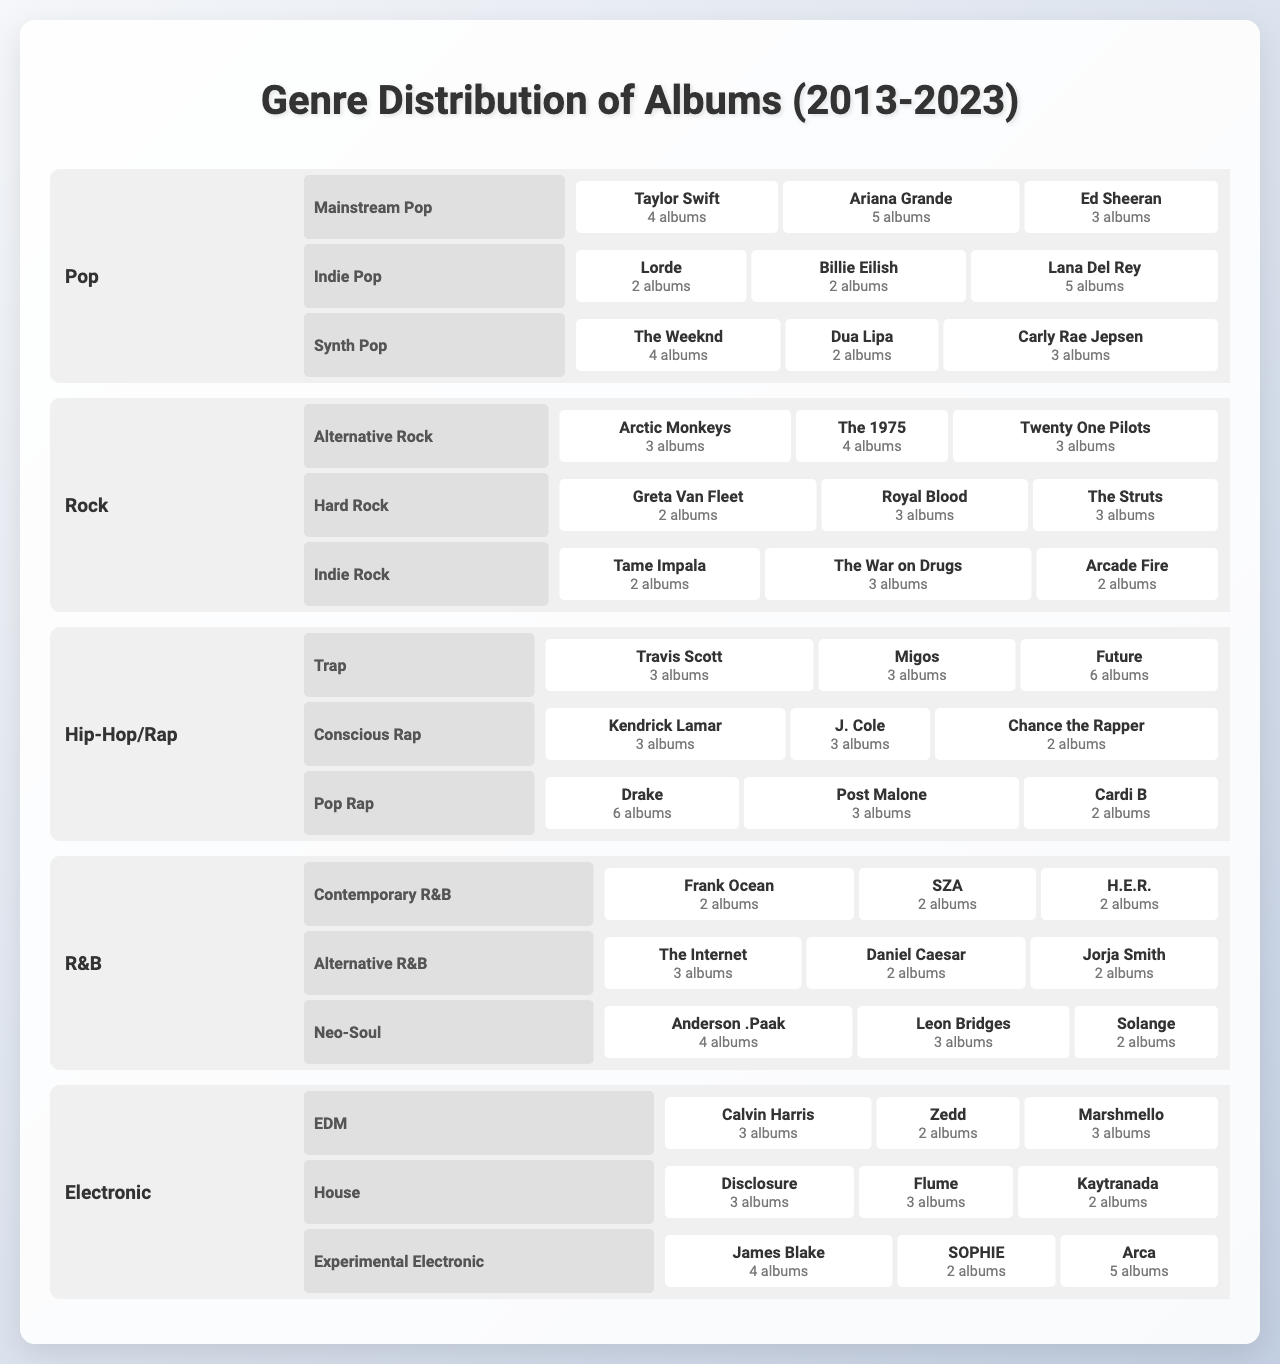What genre has the highest album count overall? To find the genre with the highest overall album count, I need to sum the album counts of all subgenres across the genres. After calculating, Pop has a total of 43 albums, Rock has 30, Hip-Hop/Rap has 41, R&B has 24, and Electronic has 30. Therefore, Pop has the highest album count.
Answer: Pop Which artist has released the most albums in the Hip-Hop/Rap genre? In the Hip-Hop/Rap genre, I will compare the album counts of Travis Scott (3), Migos (3), Future (6), Kendrick Lamar (3), J. Cole (3), Chance the Rapper (2), Drake (6), Post Malone (3), and Cardi B (2). Future and Drake both released 6 albums, so they are tied for the highest count.
Answer: Future and Drake How many albums did artists in the R&B genre release altogether? To find the total album count for the R&B genre, I need to add the counts from all subgenres: Contemporary R&B has 6 (2+2+2), Alternative R&B has 7 (3+2+2), and Neo-Soul has 9 (4+3+2). So, the total is 6 + 7 + 9 = 22 albums.
Answer: 22 Did every artist in the Rock genre release more than 2 albums? In the Rock genre, checking each artist's album counts reveals that Greta Van Fleet (2), Royal Blood (3), and The Struts (3) released albums. One artist has only released 2 albums, so not every artist in this genre released more than 2 albums.
Answer: No Which subgenre in the Electronic category has the highest album count? I will compare the album counts of each subgenre in Electronic: EDM has 8 (3+2+3), House has 8 (3+3+2), and Experimental Electronic has 11 (4+2+5). The highest is Experimental Electronic with 11 albums.
Answer: Experimental Electronic What is the average number of albums released by artists in the Pop genre? To find the average in the Pop genre, I calculate the total number of albums (4+5+3+2+2+5+4+2+3) = 30 albums from 9 artists. The average is 30/9 ≈ 3.33.
Answer: ≈ 3.33 Is there a genre with no album counts less than 3? Checking each genre, R&B has several artists with counts of 2. Therefore, there is no genre wherein all artists have at least 3 albums.
Answer: No Which artist in Indie Pop has the highest number of albums? In Indie Pop, I see that Lana Del Rey has 5 albums, while Lorde and Billie Eilish have 2 each. Therefore, Lana Del Rey has the highest count among the Indie Pop artists.
Answer: Lana Del Rey Sum the total albums released in the Trap subgenre. The Trap subgenre consists of Travis Scott (3), Migos (3), and Future (6). Therefore, the total is 3 + 3 + 6 = 12 albums released in the Trap subgenre.
Answer: 12 Which subgenre of Rock has released the least number of albums? I will sum the counts of each Rock subgenre: Alternative Rock is 10 (3+4+3), Hard Rock is 8 (2+3+3), and Indie Rock is 7 (2+3+2). The subgenre with the least total is Indie Rock with 7 albums.
Answer: Indie Rock 